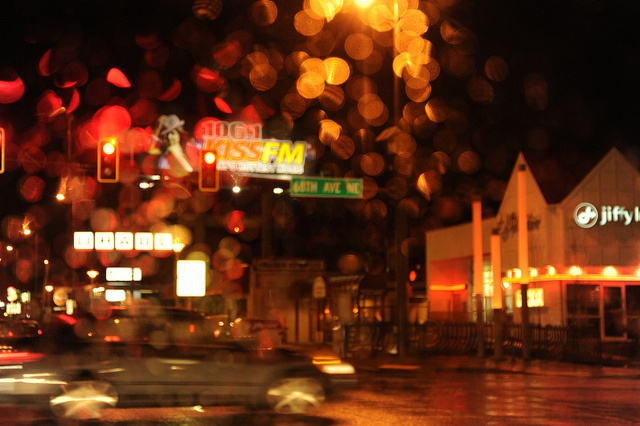Describe the objects in this image and their specific colors. I can see car in black, maroon, and brown tones, car in black, maroon, and brown tones, traffic light in black, red, brown, and maroon tones, traffic light in black, maroon, and red tones, and traffic light in black, maroon, and red tones in this image. 